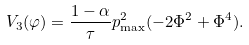Convert formula to latex. <formula><loc_0><loc_0><loc_500><loc_500>V _ { 3 } ( \varphi ) = \frac { 1 - \alpha } { \tau } p _ { \max } ^ { 2 } ( - 2 \Phi ^ { 2 } + \Phi ^ { 4 } ) .</formula> 